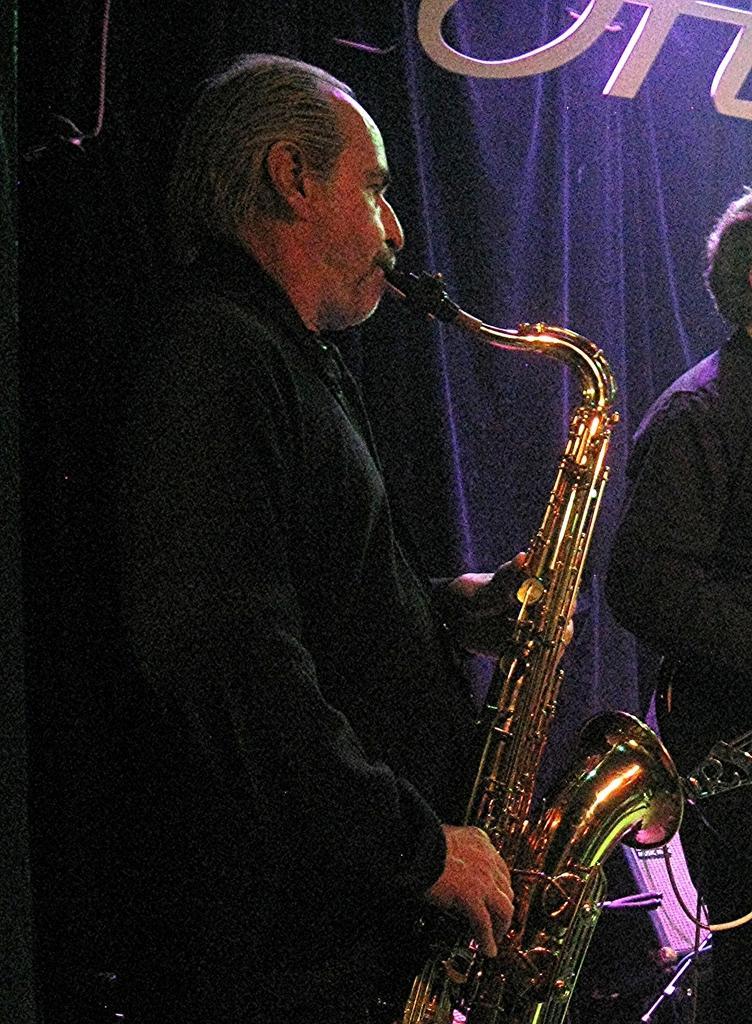Could you give a brief overview of what you see in this image? In this image I can see a man is playing the trumpet, he wore black color coat. On the right side there is another person and there is a blue color curtain, in this image. 